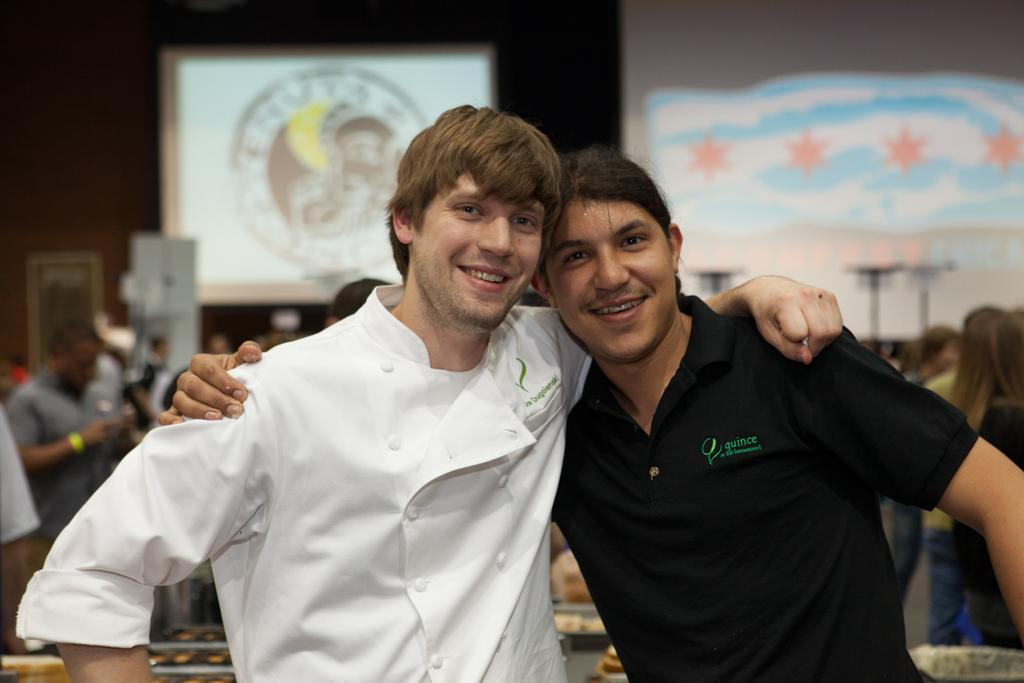How many people are in the image? There are two people in the image. What expressions do the people in the image have? The two people are smiling. Can you describe the background of the image? The background of the image is blurred. What else can be seen in the background of the image? There are people and hoardings visible in the background. Can you tell me how many cherries are on the key held by the fairies in the image? There are no cherries, keys, or fairies present in the image. 